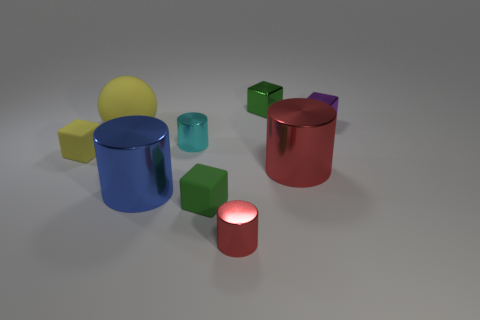There is another small shiny object that is the same shape as the cyan object; what color is it?
Keep it short and to the point. Red. The blue cylinder has what size?
Keep it short and to the point. Large. What color is the tiny metallic cube that is right of the tiny object behind the purple shiny thing?
Your answer should be compact. Purple. What number of big things are to the left of the tiny cyan metal thing and behind the blue cylinder?
Ensure brevity in your answer.  1. Are there more tiny red metal things than large cyan objects?
Your answer should be compact. Yes. What material is the big yellow thing?
Provide a short and direct response. Rubber. There is a large yellow object that is behind the small yellow cube; what number of small red things are behind it?
Give a very brief answer. 0. Is the color of the big matte ball the same as the tiny thing on the left side of the cyan metallic thing?
Provide a short and direct response. Yes. What color is the other rubber block that is the same size as the yellow cube?
Offer a terse response. Green. Is there a yellow object that has the same shape as the green matte object?
Ensure brevity in your answer.  Yes. 